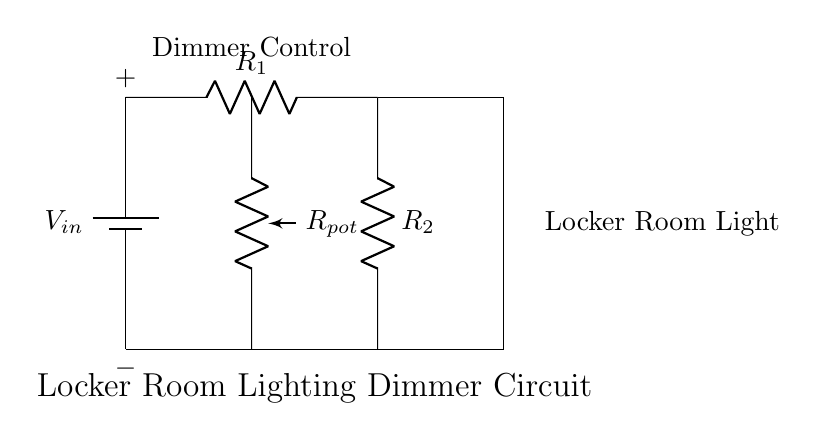What is the power supply voltage labeled as? The power supply voltage is labeled as V_in, indicating the input voltage source for the circuit.
Answer: V_in What components are used in the resistor network? The components in the resistor network are two resistors, R_1 and R_2. They are connected in series between the power supply.
Answer: R_1, R_2 What is the purpose of the potentiometer in this circuit? The potentiometer, labeled as R_pot, serves as a dimmer control to adjust the resistance and therefore the brightness of the locker room lighting.
Answer: Dimming What kind of load is connected to this circuit? The load connected to the circuit is a light bulb, used to illuminate the locker room.
Answer: Light bulb How does the voltage across the light bulb change with R_pot? As R_pot is adjusted, it changes the voltage drop across R_1 and R_2, thus varying the voltage across the light bulb and its brightness.
Answer: Varies What is the connection type of R_1 and R_2 in this dimming circuit? R_1 and R_2 are connected in series, allowing for the formation of a voltage divider that adjusts the output voltage for the light bulb based on the total resistance.
Answer: Series 